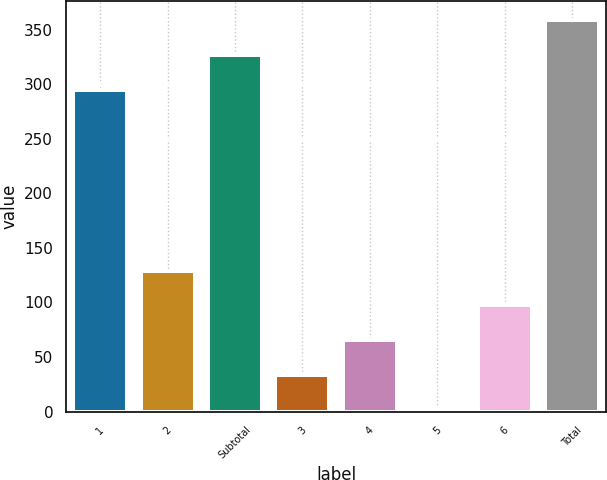Convert chart. <chart><loc_0><loc_0><loc_500><loc_500><bar_chart><fcel>1<fcel>2<fcel>Subtotal<fcel>3<fcel>4<fcel>5<fcel>6<fcel>Total<nl><fcel>295<fcel>129.15<fcel>326.81<fcel>33.72<fcel>65.53<fcel>1.91<fcel>97.34<fcel>358.62<nl></chart> 